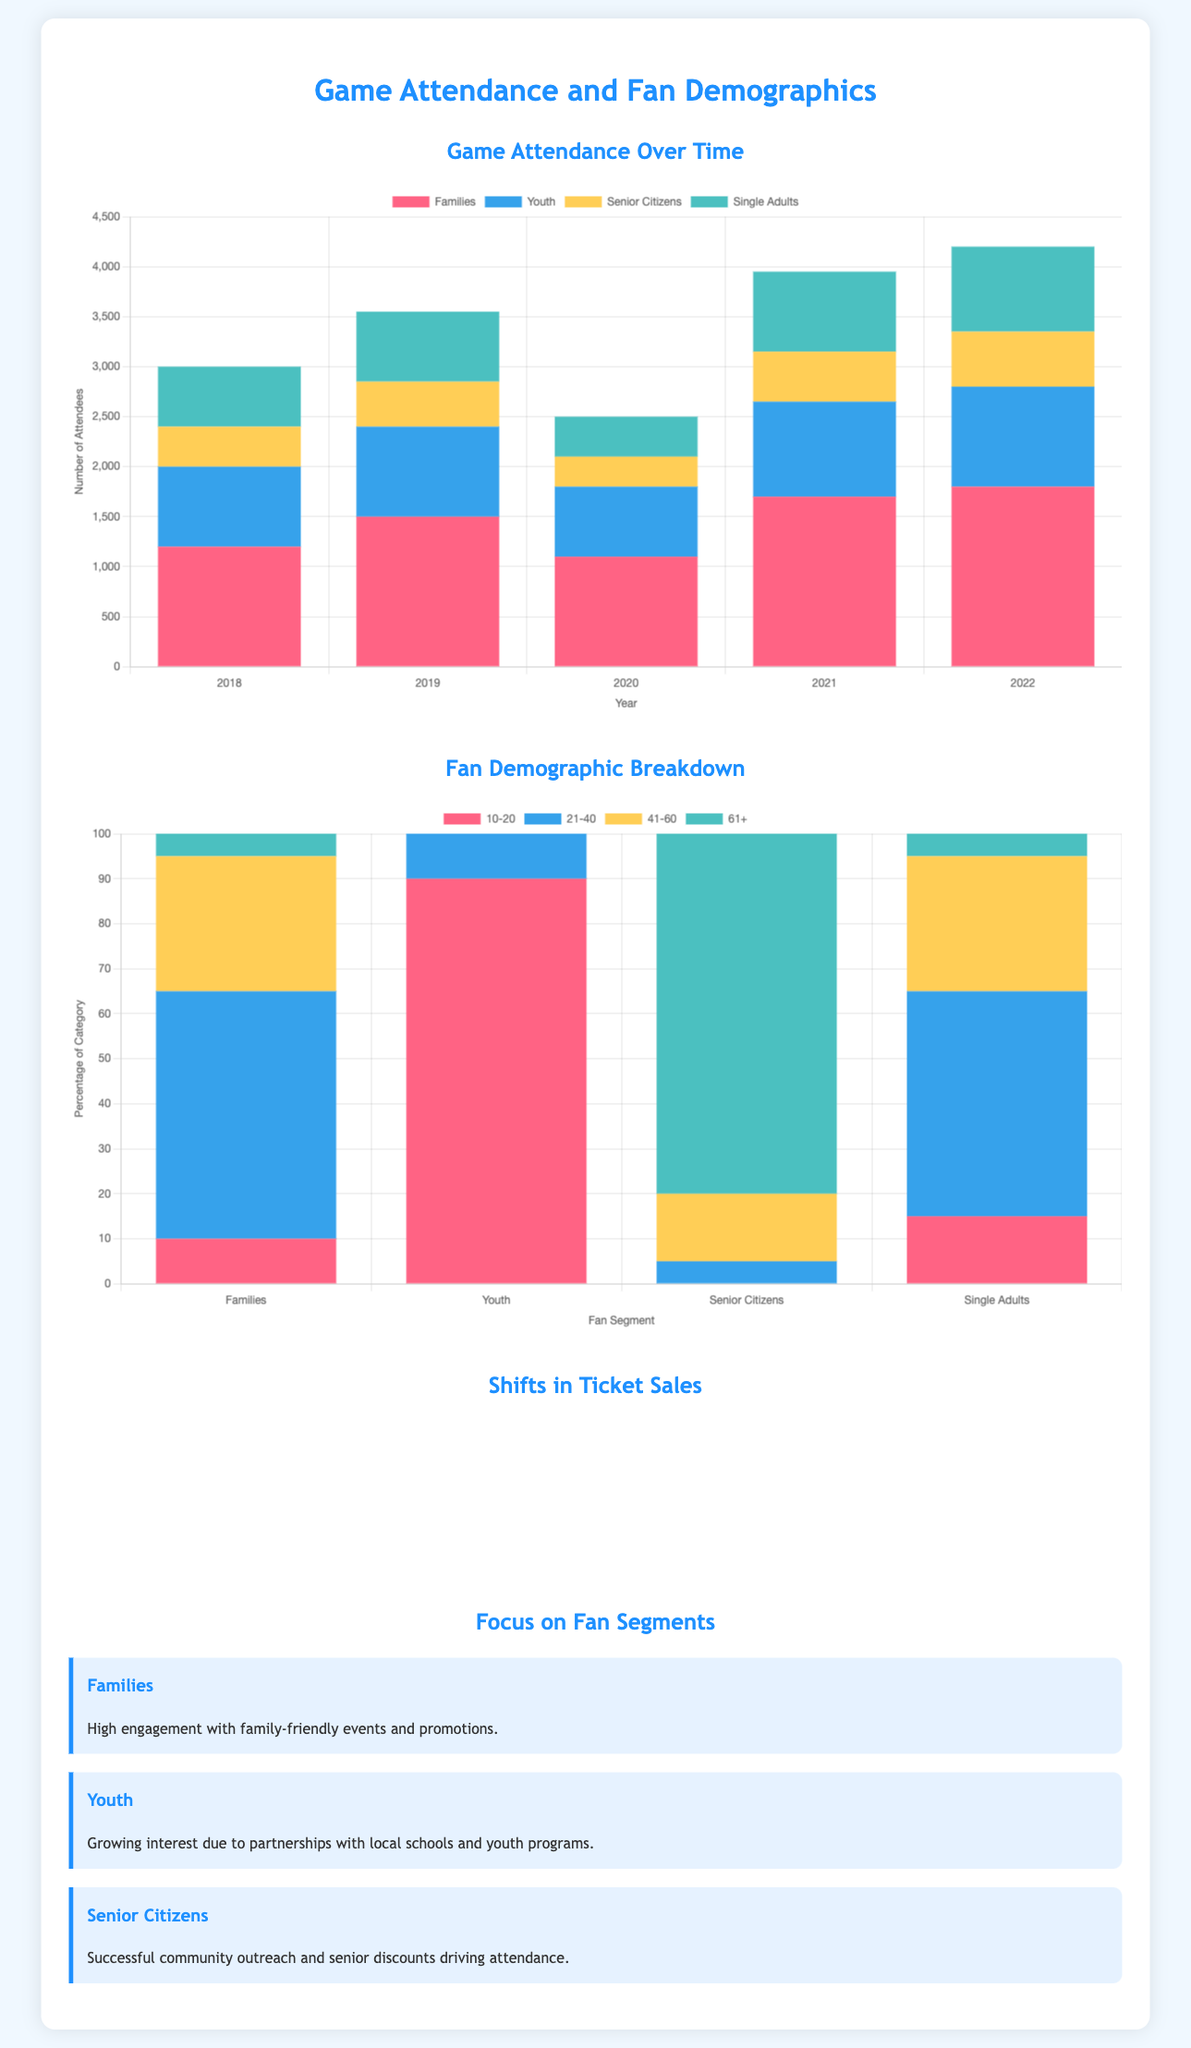what year had the highest attendance from families? The highest attendance from families is observed in 2022, with 1800 attendees.
Answer: 2022 how many youth attended games in 2020? The data shows that 700 youth attended games in 2020.
Answer: 700 what percentage of senior citizens are in the 61+ demographic? The percentage of senior citizens in the 61+ demographic is 80%.
Answer: 80% which fan segment had the least attendance in 2019? The fan segment with the least attendance in 2019 was senior citizens, with 450 attendees.
Answer: senior citizens what is the total number of attendees from single adults in 2021? The total number of attendees from single adults in 2021 is 800.
Answer: 800 in what year did youth attendance first exceed 900? Youth attendance first exceeded 900 in 2019.
Answer: 2019 how many total segments are represented in the fan demographic breakdown? The fan demographic breakdown represents four segments: Families, Youth, Senior Citizens, and Single Adults.
Answer: four segments which demographic shows the most engagement according to the focus segments? Families show the most engagement according to the focus segments.
Answer: Families what type of chart is used to illustrate shifts in ticket sales? A Sankey diagram is used to illustrate shifts in ticket sales.
Answer: Sankey diagram 